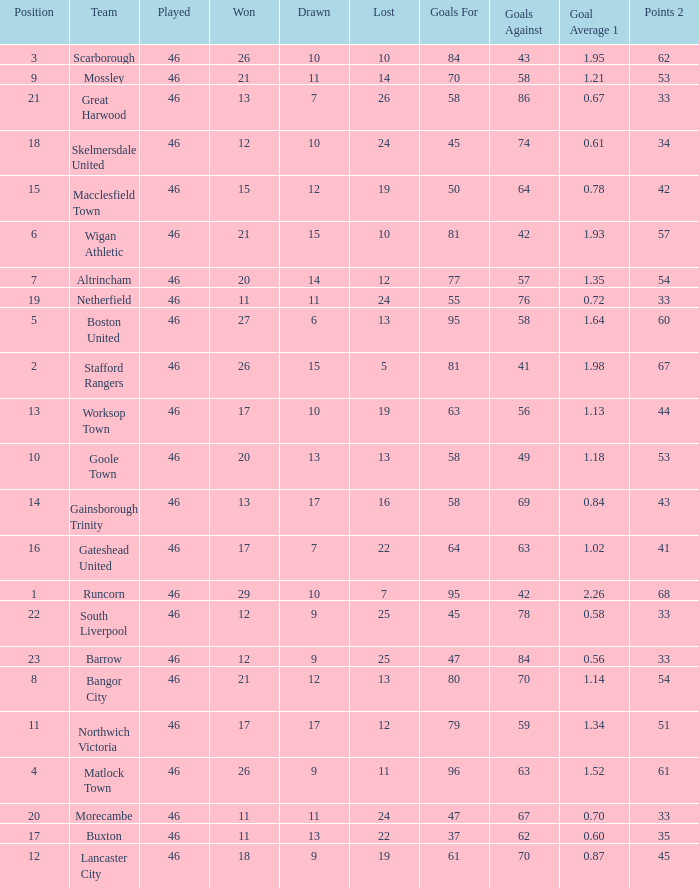How many times did the Lancaster City team play? 1.0. 